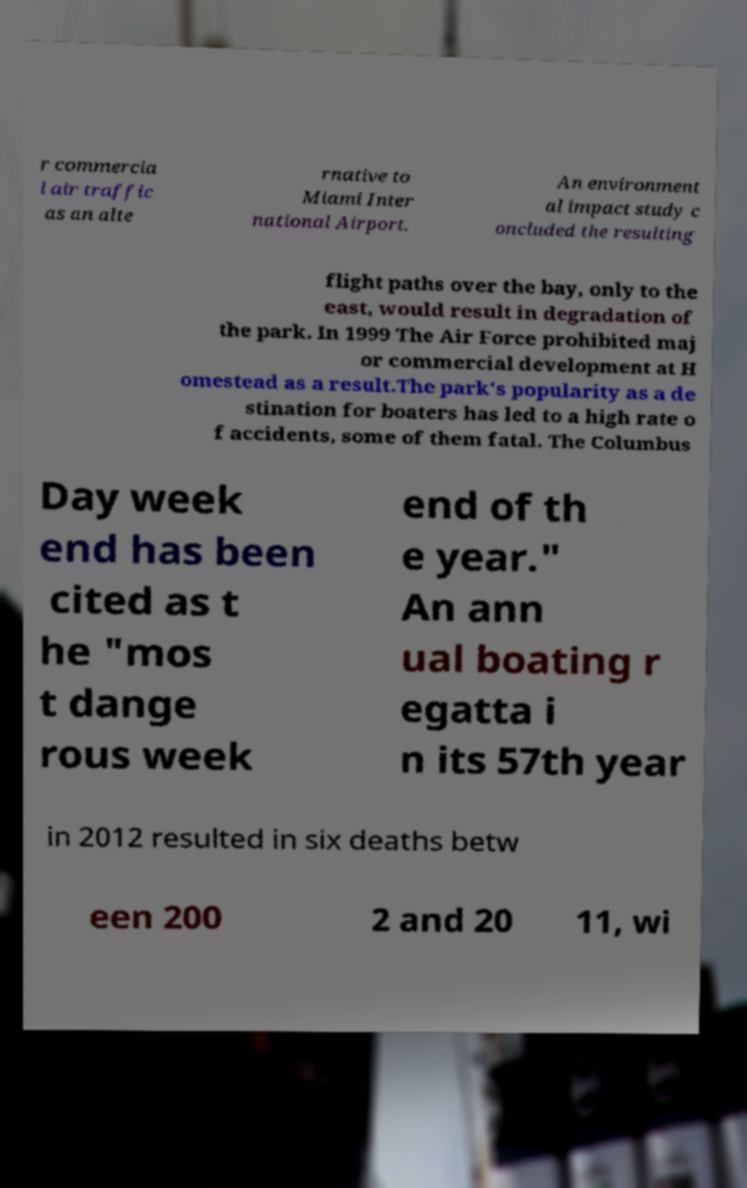I need the written content from this picture converted into text. Can you do that? r commercia l air traffic as an alte rnative to Miami Inter national Airport. An environment al impact study c oncluded the resulting flight paths over the bay, only to the east, would result in degradation of the park. In 1999 The Air Force prohibited maj or commercial development at H omestead as a result.The park's popularity as a de stination for boaters has led to a high rate o f accidents, some of them fatal. The Columbus Day week end has been cited as t he "mos t dange rous week end of th e year." An ann ual boating r egatta i n its 57th year in 2012 resulted in six deaths betw een 200 2 and 20 11, wi 